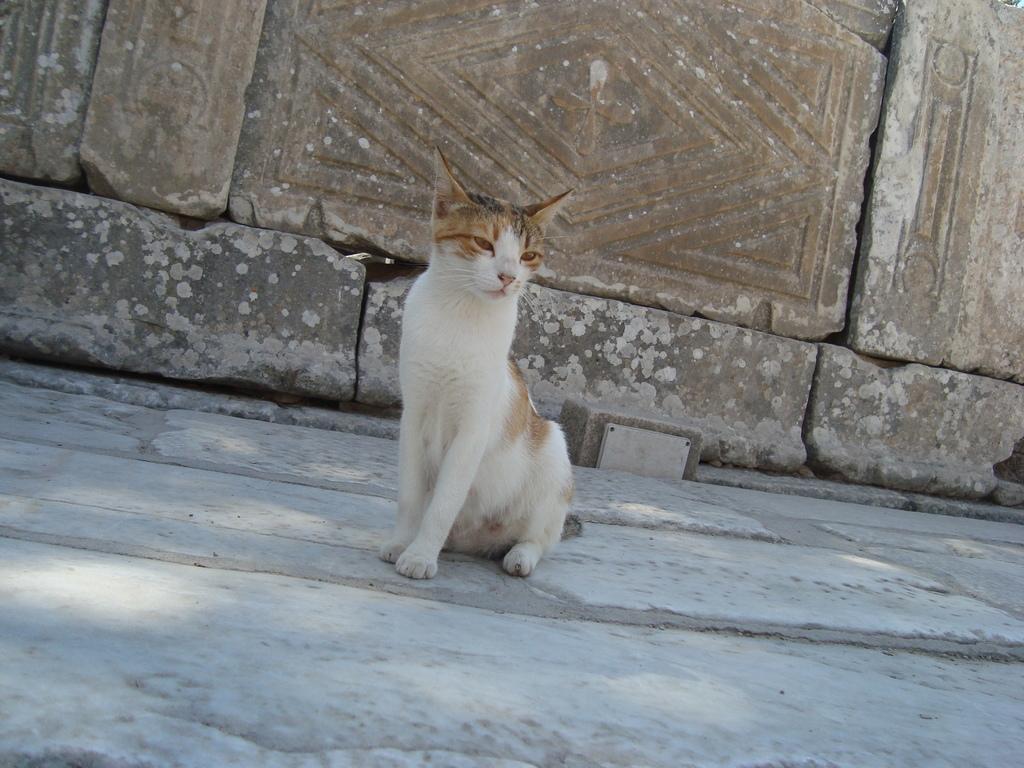Please provide a concise description of this image. There is a cat on the ground. In the back there is a wall with bricks. 